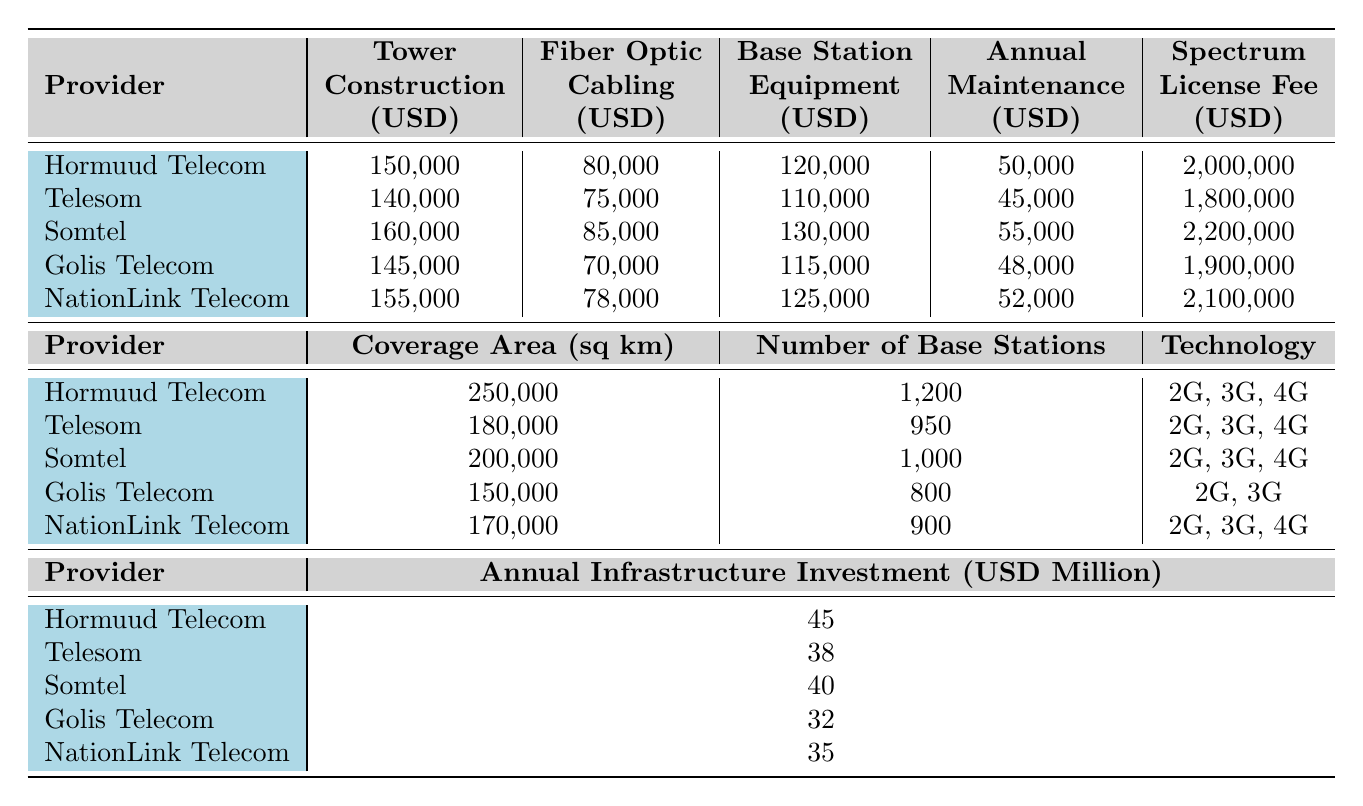What is the total cost of tower construction for Hormuud Telecom? According to the table, the tower construction cost for Hormuud Telecom is listed as 150,000 USD.
Answer: 150,000 USD Which telecom provider has the highest fiber optic cabling cost? Upon reviewing the fiber optic cabling costs, Somtel has the highest cost at 85,000 USD.
Answer: Somtel What is the average annual maintenance cost across all providers? The annual maintenance costs are: 50,000, 45,000, 55,000, 48,000, and 52,000 USD. Their sum is 250,000, and dividing by 5 gives an average of 50,000 USD.
Answer: 50,000 USD How much more does Somtel spend on spectrum license fees compared to Telesom? Somtel's spectrum license fee is 2,200,000 USD, while Telesom's is 1,800,000 USD. The difference is 2,200,000 - 1,800,000 = 400,000 USD.
Answer: 400,000 USD What is the total investment in annual infrastructure for Golis Telecom and NationLink Telecom combined? Golis Telecom’s investment is 32 million USD, and NationLink Telecom's is 35 million USD. Adding these gives: 32 + 35 = 67 million USD.
Answer: 67 million USD Which telecom provider has the most number of base stations? The number of base stations for each provider is: 1200, 950, 1000, 800, and 900. Hormuud Telecom has the highest number at 1200.
Answer: Hormuud Telecom Is Golis Telecom using 4G technology? The technology deployment for Golis Telecom is listed as 2G and 3G, indicating that it does not use 4G technology.
Answer: No What is the total coverage area for all providers? The coverage areas are: 250,000, 180,000, 200,000, 150,000, and 170,000 sq km. Summing these values gives: 250,000 + 180,000 + 200,000 + 150,000 + 170,000 = 1,050,000 sq km.
Answer: 1,050,000 sq km Which provider has the lowest total infrastructure investment? The investments are 45, 38, 40, 32, and 35 million USD. Golis Telecom has the lowest investment at 32 million USD.
Answer: Golis Telecom Which telecom provider spends the most on base station equipment? The costs for base station equipment are: 120,000, 110,000, 130,000, 115,000, and 125,000 USD. Somtel spends the most at 130,000 USD.
Answer: Somtel 